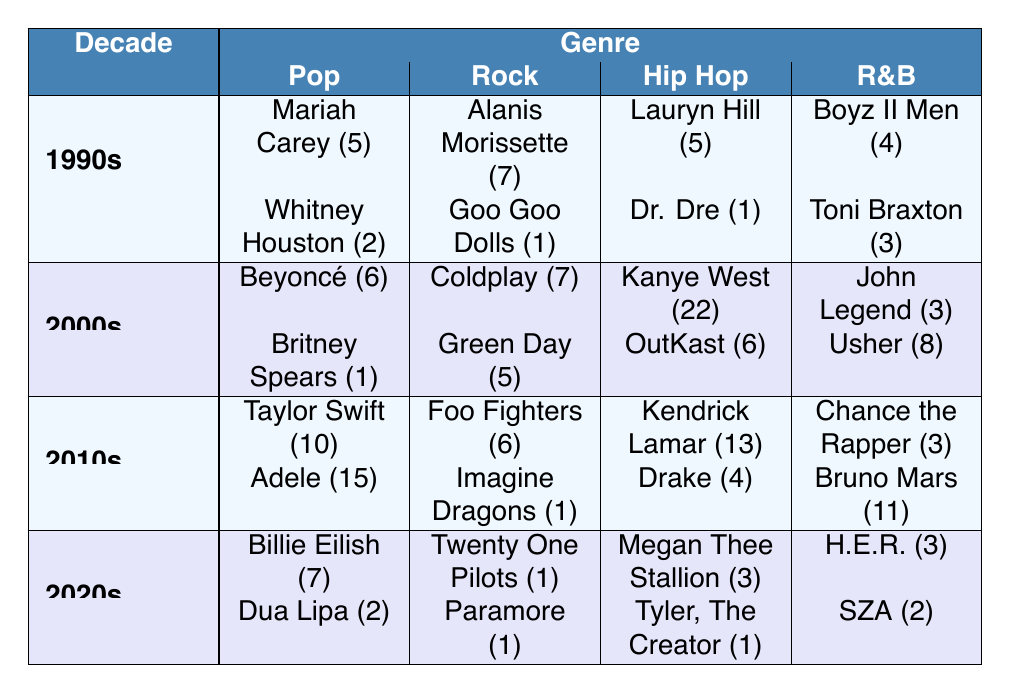What artist won the most Grammys in the 2000s? According to the 2000s data, Kanye West won 22 Grammys, which is higher than any other artist in that decade.
Answer: Kanye West Which decade had the highest total Grammy wins in the R&B genre? Adding the total R&B awards: 1990s (7), 2000s (11), 2010s (14), and 2020s (5), we get 0 + 4 + 8 + 3 + 0 + 11 + 2 = 35. The 2010s had 14, which is the highest among the decades.
Answer: 2010s Did any artist win more than 10 Grammys in the 2010s? Yes, both Taylor Swift (10) and Adele (15) won more than 10 Grammys in the 2010s.
Answer: Yes What is the total number of Grammy wins by Pop artists across all decades? The total for Pop artists is: 5 (1990s) + 6 (2000s) + 10 (2010s) + 7 (2020s) = 28.
Answer: 28 Is Lauryn Hill the only Hip Hop artist from the 1990s to win more than one Grammy? Yes, she won 5 Grammys, while Dr. Dre only won 1, making Lauryn Hill the only one with more than one award in that category for the 1990s.
Answer: Yes Which genre had the least total Grammy wins in the 2020s? Each genre's total Grammy wins in the 2020s is: Pop (9), Rock (2), Hip Hop (4), R&B (5). Rock had the least with 2 wins.
Answer: Rock How many more Grammy wins did Coldplay have compared to Green Day in the 2000s? Coldplay won 7 Grammys while Green Day won 5 Grammys in the 2000s. The difference is 7 - 5 = 2.
Answer: 2 Which decade saw the highest number of Grammy wins for artists in the Rock genre? The totals for Rock are: 1990s (8), 2000s (12), 2010s (7), 2020s (2). The 2000s had the highest at 12.
Answer: 2000s Was Billie Eilish more successful than Dua Lipa in terms of Grammy wins in the 2020s? Yes, Billie Eilish won 7 Grammys while Dua Lipa won 2, making Billie more successful in this regard during the specified decade.
Answer: Yes Which artist won the least number of Grammys in the Hip Hop genre across all decades? Adding the Hip Hop artists' awards: Lauryn Hill (5), Dr. Dre (1), Kanye West (22), OutKast (6), Kendrick Lamar (13), Drake (4), Megan Thee Stallion (3), Tyler, The Creator (1). Dr. Dre and Tyler, The Creator both won 1 Grammy, which is the least.
Answer: Dr. Dre and Tyler, The Creator 